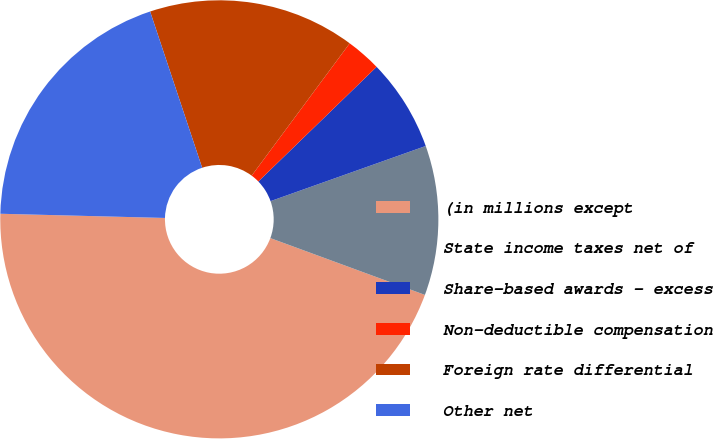Convert chart to OTSL. <chart><loc_0><loc_0><loc_500><loc_500><pie_chart><fcel>(in millions except<fcel>State income taxes net of<fcel>Share-based awards - excess<fcel>Non-deductible compensation<fcel>Foreign rate differential<fcel>Other net<nl><fcel>44.8%<fcel>11.04%<fcel>6.82%<fcel>2.6%<fcel>15.26%<fcel>19.48%<nl></chart> 